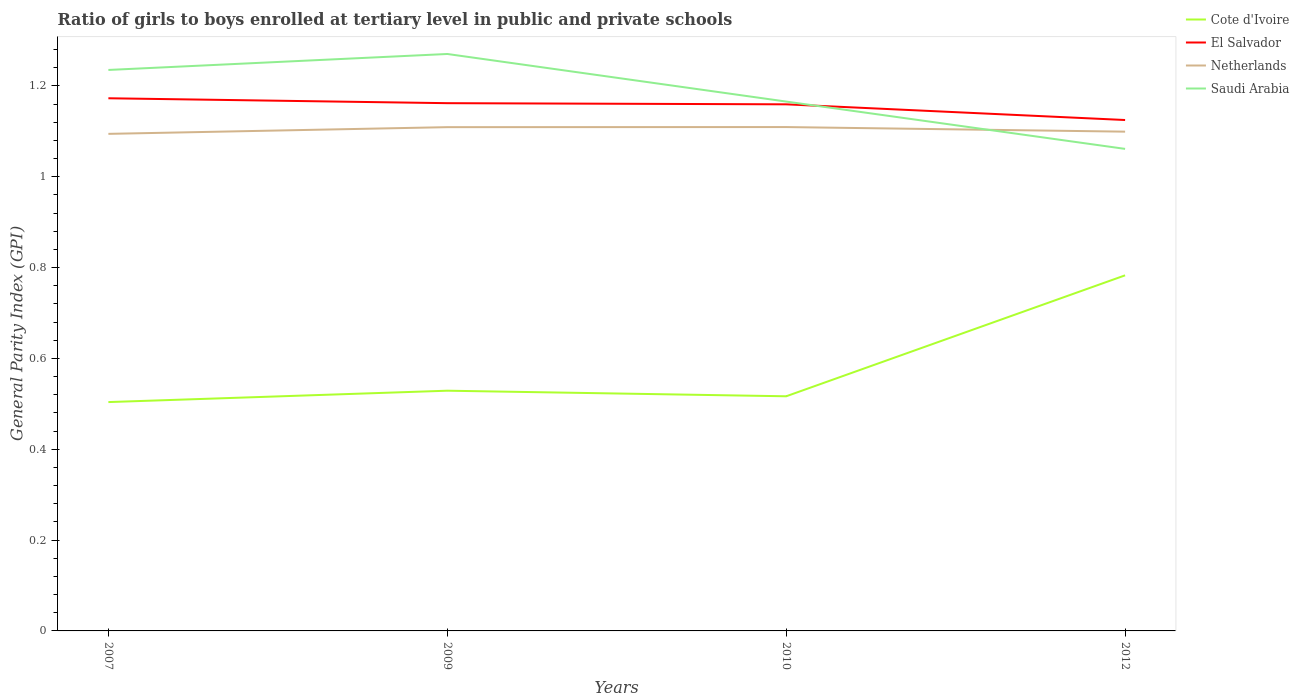Across all years, what is the maximum general parity index in Saudi Arabia?
Offer a terse response. 1.06. In which year was the general parity index in Saudi Arabia maximum?
Give a very brief answer. 2012. What is the total general parity index in Cote d'Ivoire in the graph?
Make the answer very short. 0.01. What is the difference between the highest and the second highest general parity index in Saudi Arabia?
Ensure brevity in your answer.  0.21. What is the difference between the highest and the lowest general parity index in Saudi Arabia?
Provide a short and direct response. 2. How many lines are there?
Provide a succinct answer. 4. Are the values on the major ticks of Y-axis written in scientific E-notation?
Provide a short and direct response. No. Where does the legend appear in the graph?
Your response must be concise. Top right. What is the title of the graph?
Ensure brevity in your answer.  Ratio of girls to boys enrolled at tertiary level in public and private schools. Does "Guinea" appear as one of the legend labels in the graph?
Offer a very short reply. No. What is the label or title of the X-axis?
Provide a short and direct response. Years. What is the label or title of the Y-axis?
Give a very brief answer. General Parity Index (GPI). What is the General Parity Index (GPI) in Cote d'Ivoire in 2007?
Give a very brief answer. 0.5. What is the General Parity Index (GPI) of El Salvador in 2007?
Offer a very short reply. 1.17. What is the General Parity Index (GPI) in Netherlands in 2007?
Your response must be concise. 1.09. What is the General Parity Index (GPI) of Saudi Arabia in 2007?
Make the answer very short. 1.24. What is the General Parity Index (GPI) in Cote d'Ivoire in 2009?
Your answer should be compact. 0.53. What is the General Parity Index (GPI) of El Salvador in 2009?
Offer a terse response. 1.16. What is the General Parity Index (GPI) in Netherlands in 2009?
Offer a terse response. 1.11. What is the General Parity Index (GPI) in Saudi Arabia in 2009?
Provide a succinct answer. 1.27. What is the General Parity Index (GPI) of Cote d'Ivoire in 2010?
Your answer should be compact. 0.52. What is the General Parity Index (GPI) in El Salvador in 2010?
Give a very brief answer. 1.16. What is the General Parity Index (GPI) in Netherlands in 2010?
Your response must be concise. 1.11. What is the General Parity Index (GPI) of Saudi Arabia in 2010?
Provide a short and direct response. 1.17. What is the General Parity Index (GPI) in Cote d'Ivoire in 2012?
Your answer should be very brief. 0.78. What is the General Parity Index (GPI) of El Salvador in 2012?
Your answer should be compact. 1.13. What is the General Parity Index (GPI) in Netherlands in 2012?
Give a very brief answer. 1.1. What is the General Parity Index (GPI) in Saudi Arabia in 2012?
Your answer should be very brief. 1.06. Across all years, what is the maximum General Parity Index (GPI) in Cote d'Ivoire?
Give a very brief answer. 0.78. Across all years, what is the maximum General Parity Index (GPI) in El Salvador?
Offer a terse response. 1.17. Across all years, what is the maximum General Parity Index (GPI) of Netherlands?
Ensure brevity in your answer.  1.11. Across all years, what is the maximum General Parity Index (GPI) in Saudi Arabia?
Your response must be concise. 1.27. Across all years, what is the minimum General Parity Index (GPI) in Cote d'Ivoire?
Your answer should be compact. 0.5. Across all years, what is the minimum General Parity Index (GPI) of El Salvador?
Your response must be concise. 1.13. Across all years, what is the minimum General Parity Index (GPI) in Netherlands?
Ensure brevity in your answer.  1.09. Across all years, what is the minimum General Parity Index (GPI) of Saudi Arabia?
Provide a succinct answer. 1.06. What is the total General Parity Index (GPI) of Cote d'Ivoire in the graph?
Your response must be concise. 2.33. What is the total General Parity Index (GPI) in El Salvador in the graph?
Make the answer very short. 4.62. What is the total General Parity Index (GPI) in Netherlands in the graph?
Offer a very short reply. 4.41. What is the total General Parity Index (GPI) in Saudi Arabia in the graph?
Offer a very short reply. 4.73. What is the difference between the General Parity Index (GPI) of Cote d'Ivoire in 2007 and that in 2009?
Make the answer very short. -0.03. What is the difference between the General Parity Index (GPI) of El Salvador in 2007 and that in 2009?
Your answer should be compact. 0.01. What is the difference between the General Parity Index (GPI) of Netherlands in 2007 and that in 2009?
Your response must be concise. -0.01. What is the difference between the General Parity Index (GPI) of Saudi Arabia in 2007 and that in 2009?
Your answer should be compact. -0.04. What is the difference between the General Parity Index (GPI) of Cote d'Ivoire in 2007 and that in 2010?
Offer a very short reply. -0.01. What is the difference between the General Parity Index (GPI) of El Salvador in 2007 and that in 2010?
Ensure brevity in your answer.  0.01. What is the difference between the General Parity Index (GPI) in Netherlands in 2007 and that in 2010?
Offer a terse response. -0.01. What is the difference between the General Parity Index (GPI) in Saudi Arabia in 2007 and that in 2010?
Give a very brief answer. 0.07. What is the difference between the General Parity Index (GPI) of Cote d'Ivoire in 2007 and that in 2012?
Provide a short and direct response. -0.28. What is the difference between the General Parity Index (GPI) of El Salvador in 2007 and that in 2012?
Your response must be concise. 0.05. What is the difference between the General Parity Index (GPI) in Netherlands in 2007 and that in 2012?
Make the answer very short. -0. What is the difference between the General Parity Index (GPI) of Saudi Arabia in 2007 and that in 2012?
Make the answer very short. 0.17. What is the difference between the General Parity Index (GPI) in Cote d'Ivoire in 2009 and that in 2010?
Ensure brevity in your answer.  0.01. What is the difference between the General Parity Index (GPI) of El Salvador in 2009 and that in 2010?
Provide a succinct answer. 0. What is the difference between the General Parity Index (GPI) of Netherlands in 2009 and that in 2010?
Keep it short and to the point. -0. What is the difference between the General Parity Index (GPI) in Saudi Arabia in 2009 and that in 2010?
Provide a succinct answer. 0.1. What is the difference between the General Parity Index (GPI) of Cote d'Ivoire in 2009 and that in 2012?
Your response must be concise. -0.25. What is the difference between the General Parity Index (GPI) in El Salvador in 2009 and that in 2012?
Give a very brief answer. 0.04. What is the difference between the General Parity Index (GPI) of Netherlands in 2009 and that in 2012?
Offer a very short reply. 0.01. What is the difference between the General Parity Index (GPI) of Saudi Arabia in 2009 and that in 2012?
Give a very brief answer. 0.21. What is the difference between the General Parity Index (GPI) of Cote d'Ivoire in 2010 and that in 2012?
Keep it short and to the point. -0.27. What is the difference between the General Parity Index (GPI) in El Salvador in 2010 and that in 2012?
Make the answer very short. 0.03. What is the difference between the General Parity Index (GPI) in Netherlands in 2010 and that in 2012?
Provide a short and direct response. 0.01. What is the difference between the General Parity Index (GPI) of Saudi Arabia in 2010 and that in 2012?
Give a very brief answer. 0.1. What is the difference between the General Parity Index (GPI) of Cote d'Ivoire in 2007 and the General Parity Index (GPI) of El Salvador in 2009?
Offer a terse response. -0.66. What is the difference between the General Parity Index (GPI) of Cote d'Ivoire in 2007 and the General Parity Index (GPI) of Netherlands in 2009?
Make the answer very short. -0.61. What is the difference between the General Parity Index (GPI) in Cote d'Ivoire in 2007 and the General Parity Index (GPI) in Saudi Arabia in 2009?
Provide a short and direct response. -0.77. What is the difference between the General Parity Index (GPI) in El Salvador in 2007 and the General Parity Index (GPI) in Netherlands in 2009?
Offer a terse response. 0.06. What is the difference between the General Parity Index (GPI) in El Salvador in 2007 and the General Parity Index (GPI) in Saudi Arabia in 2009?
Give a very brief answer. -0.1. What is the difference between the General Parity Index (GPI) of Netherlands in 2007 and the General Parity Index (GPI) of Saudi Arabia in 2009?
Offer a very short reply. -0.18. What is the difference between the General Parity Index (GPI) in Cote d'Ivoire in 2007 and the General Parity Index (GPI) in El Salvador in 2010?
Offer a terse response. -0.66. What is the difference between the General Parity Index (GPI) in Cote d'Ivoire in 2007 and the General Parity Index (GPI) in Netherlands in 2010?
Provide a succinct answer. -0.61. What is the difference between the General Parity Index (GPI) in Cote d'Ivoire in 2007 and the General Parity Index (GPI) in Saudi Arabia in 2010?
Offer a terse response. -0.66. What is the difference between the General Parity Index (GPI) of El Salvador in 2007 and the General Parity Index (GPI) of Netherlands in 2010?
Give a very brief answer. 0.06. What is the difference between the General Parity Index (GPI) in El Salvador in 2007 and the General Parity Index (GPI) in Saudi Arabia in 2010?
Keep it short and to the point. 0.01. What is the difference between the General Parity Index (GPI) in Netherlands in 2007 and the General Parity Index (GPI) in Saudi Arabia in 2010?
Your answer should be very brief. -0.07. What is the difference between the General Parity Index (GPI) of Cote d'Ivoire in 2007 and the General Parity Index (GPI) of El Salvador in 2012?
Provide a succinct answer. -0.62. What is the difference between the General Parity Index (GPI) in Cote d'Ivoire in 2007 and the General Parity Index (GPI) in Netherlands in 2012?
Provide a short and direct response. -0.6. What is the difference between the General Parity Index (GPI) in Cote d'Ivoire in 2007 and the General Parity Index (GPI) in Saudi Arabia in 2012?
Ensure brevity in your answer.  -0.56. What is the difference between the General Parity Index (GPI) of El Salvador in 2007 and the General Parity Index (GPI) of Netherlands in 2012?
Your answer should be compact. 0.07. What is the difference between the General Parity Index (GPI) of El Salvador in 2007 and the General Parity Index (GPI) of Saudi Arabia in 2012?
Make the answer very short. 0.11. What is the difference between the General Parity Index (GPI) of Netherlands in 2007 and the General Parity Index (GPI) of Saudi Arabia in 2012?
Your answer should be very brief. 0.03. What is the difference between the General Parity Index (GPI) in Cote d'Ivoire in 2009 and the General Parity Index (GPI) in El Salvador in 2010?
Your response must be concise. -0.63. What is the difference between the General Parity Index (GPI) of Cote d'Ivoire in 2009 and the General Parity Index (GPI) of Netherlands in 2010?
Your answer should be very brief. -0.58. What is the difference between the General Parity Index (GPI) in Cote d'Ivoire in 2009 and the General Parity Index (GPI) in Saudi Arabia in 2010?
Offer a terse response. -0.64. What is the difference between the General Parity Index (GPI) of El Salvador in 2009 and the General Parity Index (GPI) of Netherlands in 2010?
Offer a terse response. 0.05. What is the difference between the General Parity Index (GPI) of El Salvador in 2009 and the General Parity Index (GPI) of Saudi Arabia in 2010?
Your answer should be compact. -0. What is the difference between the General Parity Index (GPI) of Netherlands in 2009 and the General Parity Index (GPI) of Saudi Arabia in 2010?
Ensure brevity in your answer.  -0.06. What is the difference between the General Parity Index (GPI) of Cote d'Ivoire in 2009 and the General Parity Index (GPI) of El Salvador in 2012?
Your answer should be very brief. -0.6. What is the difference between the General Parity Index (GPI) of Cote d'Ivoire in 2009 and the General Parity Index (GPI) of Netherlands in 2012?
Your answer should be compact. -0.57. What is the difference between the General Parity Index (GPI) of Cote d'Ivoire in 2009 and the General Parity Index (GPI) of Saudi Arabia in 2012?
Your answer should be very brief. -0.53. What is the difference between the General Parity Index (GPI) in El Salvador in 2009 and the General Parity Index (GPI) in Netherlands in 2012?
Keep it short and to the point. 0.06. What is the difference between the General Parity Index (GPI) in El Salvador in 2009 and the General Parity Index (GPI) in Saudi Arabia in 2012?
Ensure brevity in your answer.  0.1. What is the difference between the General Parity Index (GPI) of Netherlands in 2009 and the General Parity Index (GPI) of Saudi Arabia in 2012?
Your answer should be compact. 0.05. What is the difference between the General Parity Index (GPI) in Cote d'Ivoire in 2010 and the General Parity Index (GPI) in El Salvador in 2012?
Your answer should be very brief. -0.61. What is the difference between the General Parity Index (GPI) in Cote d'Ivoire in 2010 and the General Parity Index (GPI) in Netherlands in 2012?
Your answer should be very brief. -0.58. What is the difference between the General Parity Index (GPI) of Cote d'Ivoire in 2010 and the General Parity Index (GPI) of Saudi Arabia in 2012?
Your answer should be very brief. -0.54. What is the difference between the General Parity Index (GPI) of El Salvador in 2010 and the General Parity Index (GPI) of Netherlands in 2012?
Your response must be concise. 0.06. What is the difference between the General Parity Index (GPI) of El Salvador in 2010 and the General Parity Index (GPI) of Saudi Arabia in 2012?
Provide a short and direct response. 0.1. What is the difference between the General Parity Index (GPI) of Netherlands in 2010 and the General Parity Index (GPI) of Saudi Arabia in 2012?
Make the answer very short. 0.05. What is the average General Parity Index (GPI) in Cote d'Ivoire per year?
Your answer should be compact. 0.58. What is the average General Parity Index (GPI) of El Salvador per year?
Offer a very short reply. 1.16. What is the average General Parity Index (GPI) in Netherlands per year?
Offer a very short reply. 1.1. What is the average General Parity Index (GPI) of Saudi Arabia per year?
Offer a terse response. 1.18. In the year 2007, what is the difference between the General Parity Index (GPI) of Cote d'Ivoire and General Parity Index (GPI) of El Salvador?
Offer a very short reply. -0.67. In the year 2007, what is the difference between the General Parity Index (GPI) of Cote d'Ivoire and General Parity Index (GPI) of Netherlands?
Provide a succinct answer. -0.59. In the year 2007, what is the difference between the General Parity Index (GPI) in Cote d'Ivoire and General Parity Index (GPI) in Saudi Arabia?
Provide a succinct answer. -0.73. In the year 2007, what is the difference between the General Parity Index (GPI) in El Salvador and General Parity Index (GPI) in Netherlands?
Provide a succinct answer. 0.08. In the year 2007, what is the difference between the General Parity Index (GPI) in El Salvador and General Parity Index (GPI) in Saudi Arabia?
Make the answer very short. -0.06. In the year 2007, what is the difference between the General Parity Index (GPI) of Netherlands and General Parity Index (GPI) of Saudi Arabia?
Your response must be concise. -0.14. In the year 2009, what is the difference between the General Parity Index (GPI) of Cote d'Ivoire and General Parity Index (GPI) of El Salvador?
Provide a succinct answer. -0.63. In the year 2009, what is the difference between the General Parity Index (GPI) of Cote d'Ivoire and General Parity Index (GPI) of Netherlands?
Your answer should be compact. -0.58. In the year 2009, what is the difference between the General Parity Index (GPI) in Cote d'Ivoire and General Parity Index (GPI) in Saudi Arabia?
Your answer should be very brief. -0.74. In the year 2009, what is the difference between the General Parity Index (GPI) of El Salvador and General Parity Index (GPI) of Netherlands?
Your answer should be very brief. 0.05. In the year 2009, what is the difference between the General Parity Index (GPI) in El Salvador and General Parity Index (GPI) in Saudi Arabia?
Ensure brevity in your answer.  -0.11. In the year 2009, what is the difference between the General Parity Index (GPI) of Netherlands and General Parity Index (GPI) of Saudi Arabia?
Your response must be concise. -0.16. In the year 2010, what is the difference between the General Parity Index (GPI) in Cote d'Ivoire and General Parity Index (GPI) in El Salvador?
Keep it short and to the point. -0.64. In the year 2010, what is the difference between the General Parity Index (GPI) in Cote d'Ivoire and General Parity Index (GPI) in Netherlands?
Your answer should be very brief. -0.59. In the year 2010, what is the difference between the General Parity Index (GPI) in Cote d'Ivoire and General Parity Index (GPI) in Saudi Arabia?
Give a very brief answer. -0.65. In the year 2010, what is the difference between the General Parity Index (GPI) in El Salvador and General Parity Index (GPI) in Netherlands?
Your answer should be compact. 0.05. In the year 2010, what is the difference between the General Parity Index (GPI) in El Salvador and General Parity Index (GPI) in Saudi Arabia?
Give a very brief answer. -0.01. In the year 2010, what is the difference between the General Parity Index (GPI) in Netherlands and General Parity Index (GPI) in Saudi Arabia?
Offer a terse response. -0.06. In the year 2012, what is the difference between the General Parity Index (GPI) in Cote d'Ivoire and General Parity Index (GPI) in El Salvador?
Provide a short and direct response. -0.34. In the year 2012, what is the difference between the General Parity Index (GPI) in Cote d'Ivoire and General Parity Index (GPI) in Netherlands?
Your answer should be compact. -0.32. In the year 2012, what is the difference between the General Parity Index (GPI) of Cote d'Ivoire and General Parity Index (GPI) of Saudi Arabia?
Your response must be concise. -0.28. In the year 2012, what is the difference between the General Parity Index (GPI) of El Salvador and General Parity Index (GPI) of Netherlands?
Your response must be concise. 0.03. In the year 2012, what is the difference between the General Parity Index (GPI) of El Salvador and General Parity Index (GPI) of Saudi Arabia?
Your answer should be very brief. 0.06. In the year 2012, what is the difference between the General Parity Index (GPI) of Netherlands and General Parity Index (GPI) of Saudi Arabia?
Provide a short and direct response. 0.04. What is the ratio of the General Parity Index (GPI) of Cote d'Ivoire in 2007 to that in 2009?
Make the answer very short. 0.95. What is the ratio of the General Parity Index (GPI) in El Salvador in 2007 to that in 2009?
Keep it short and to the point. 1.01. What is the ratio of the General Parity Index (GPI) in Netherlands in 2007 to that in 2009?
Provide a short and direct response. 0.99. What is the ratio of the General Parity Index (GPI) of Saudi Arabia in 2007 to that in 2009?
Make the answer very short. 0.97. What is the ratio of the General Parity Index (GPI) in Cote d'Ivoire in 2007 to that in 2010?
Your response must be concise. 0.98. What is the ratio of the General Parity Index (GPI) of El Salvador in 2007 to that in 2010?
Keep it short and to the point. 1.01. What is the ratio of the General Parity Index (GPI) in Netherlands in 2007 to that in 2010?
Give a very brief answer. 0.99. What is the ratio of the General Parity Index (GPI) of Saudi Arabia in 2007 to that in 2010?
Provide a succinct answer. 1.06. What is the ratio of the General Parity Index (GPI) of Cote d'Ivoire in 2007 to that in 2012?
Provide a succinct answer. 0.64. What is the ratio of the General Parity Index (GPI) of El Salvador in 2007 to that in 2012?
Provide a short and direct response. 1.04. What is the ratio of the General Parity Index (GPI) in Netherlands in 2007 to that in 2012?
Provide a succinct answer. 1. What is the ratio of the General Parity Index (GPI) in Saudi Arabia in 2007 to that in 2012?
Give a very brief answer. 1.16. What is the ratio of the General Parity Index (GPI) of Cote d'Ivoire in 2009 to that in 2010?
Keep it short and to the point. 1.02. What is the ratio of the General Parity Index (GPI) of Netherlands in 2009 to that in 2010?
Provide a succinct answer. 1. What is the ratio of the General Parity Index (GPI) of Saudi Arabia in 2009 to that in 2010?
Ensure brevity in your answer.  1.09. What is the ratio of the General Parity Index (GPI) in Cote d'Ivoire in 2009 to that in 2012?
Offer a very short reply. 0.68. What is the ratio of the General Parity Index (GPI) of El Salvador in 2009 to that in 2012?
Ensure brevity in your answer.  1.03. What is the ratio of the General Parity Index (GPI) in Saudi Arabia in 2009 to that in 2012?
Ensure brevity in your answer.  1.2. What is the ratio of the General Parity Index (GPI) in Cote d'Ivoire in 2010 to that in 2012?
Give a very brief answer. 0.66. What is the ratio of the General Parity Index (GPI) of El Salvador in 2010 to that in 2012?
Keep it short and to the point. 1.03. What is the ratio of the General Parity Index (GPI) of Netherlands in 2010 to that in 2012?
Provide a succinct answer. 1.01. What is the ratio of the General Parity Index (GPI) of Saudi Arabia in 2010 to that in 2012?
Make the answer very short. 1.1. What is the difference between the highest and the second highest General Parity Index (GPI) in Cote d'Ivoire?
Offer a very short reply. 0.25. What is the difference between the highest and the second highest General Parity Index (GPI) in El Salvador?
Provide a succinct answer. 0.01. What is the difference between the highest and the second highest General Parity Index (GPI) of Saudi Arabia?
Keep it short and to the point. 0.04. What is the difference between the highest and the lowest General Parity Index (GPI) in Cote d'Ivoire?
Offer a very short reply. 0.28. What is the difference between the highest and the lowest General Parity Index (GPI) in El Salvador?
Offer a terse response. 0.05. What is the difference between the highest and the lowest General Parity Index (GPI) in Netherlands?
Make the answer very short. 0.01. What is the difference between the highest and the lowest General Parity Index (GPI) of Saudi Arabia?
Keep it short and to the point. 0.21. 